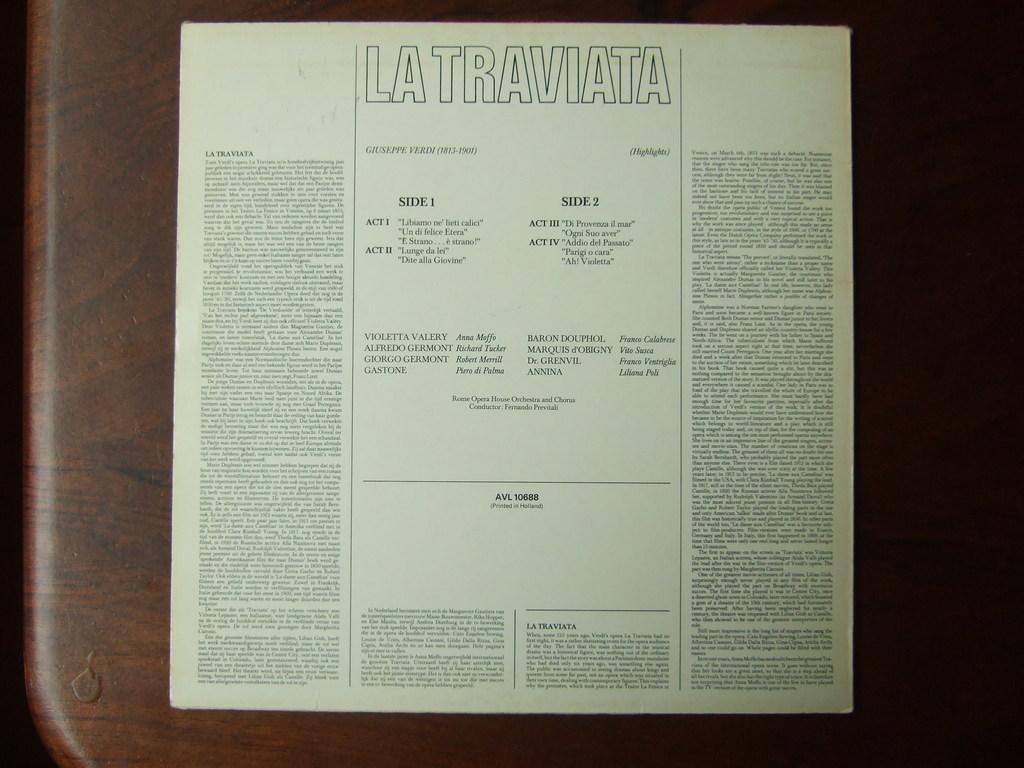<image>
Summarize the visual content of the image. An piece of paper that is titled La Traviata which shows the various acts included. 